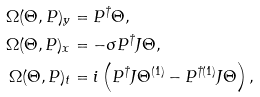<formula> <loc_0><loc_0><loc_500><loc_500>\Omega ( \Theta , P ) _ { y } & = P ^ { \dag } \Theta , \\ \Omega ( \Theta , P ) _ { x } & = - \sigma { P } ^ { \dag } J \Theta , \\ \Omega ( \Theta , P ) _ { t } & = i \left ( P ^ { \dag } J \Theta ^ { ( 1 ) } - P ^ { \dag ( 1 ) } J \Theta \right ) ,</formula> 